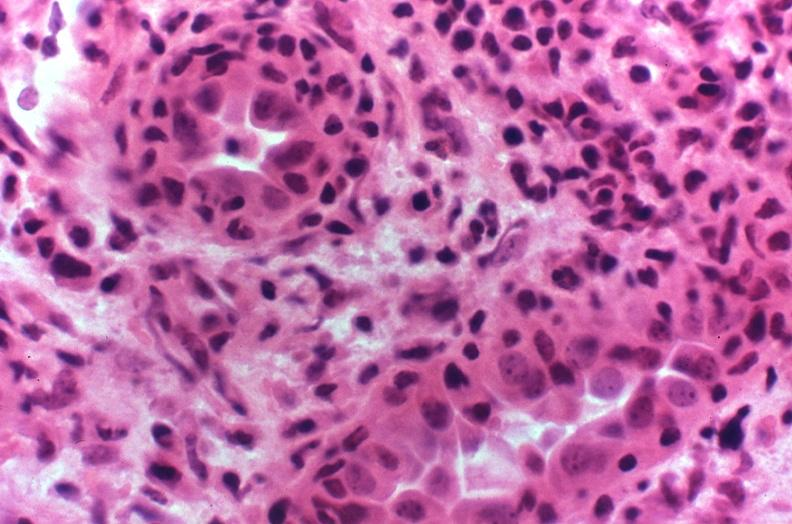does this image show kidney transplant rejection?
Answer the question using a single word or phrase. Yes 